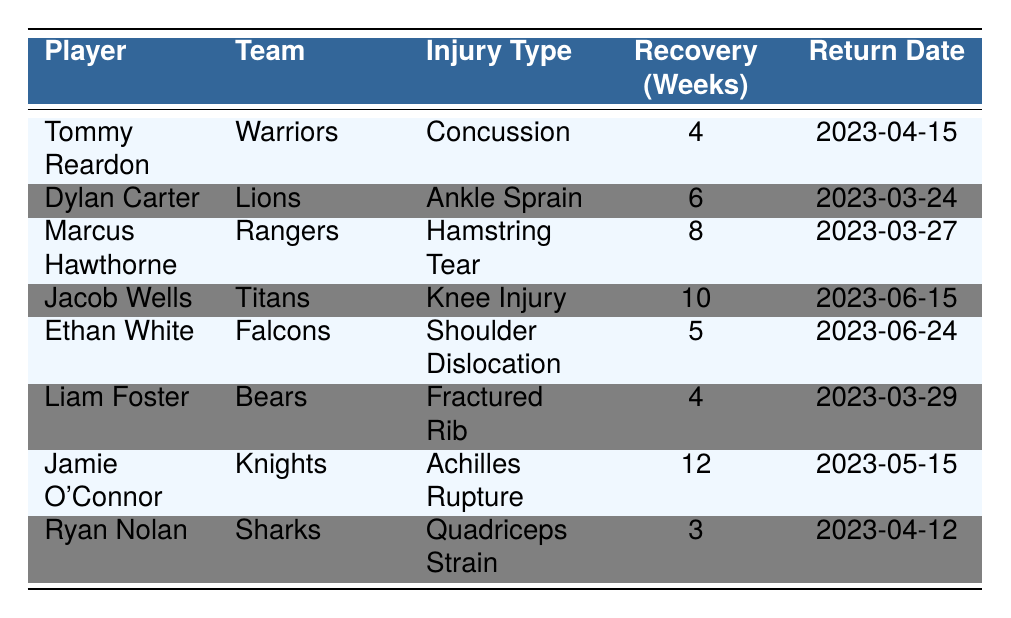What injury did Tommy Reardon have? Referring to the table, Tommy Reardon's injury type is listed as "Concussion."
Answer: Concussion Which player had the longest recovery time? By examining the recovery times in the table, Jamie O'Connor's recovery time is 12 weeks, which is the highest among all players.
Answer: Jamie O'Connor Did any players return to play before the 30th of April? Checking the return dates, both Tommy Reardon (April 15) and Liam Foster (March 29) returned before April 30.
Answer: Yes How many players sustained injuries that required more than 6 weeks of recovery? The table shows that Jamie O'Connor (12 weeks), Jacob Wells (10 weeks), and Marcus Hawthorne (8 weeks) had injuries requiring more than 6 weeks of recovery, totaling 3 players.
Answer: 3 players What is the average recovery time for the players listed? The recovery times are 4, 6, 8, 10, 5, 4, 12, and 3 weeks. Summing them yields 52 weeks for 8 players, so the average is 52/8 = 6.5 weeks.
Answer: 6.5 weeks Which team did Ryan Nolan play for, and what was his injury type? According to the table, Ryan Nolan played for the Sharks and sustained a Quadriceps Strain.
Answer: Sharks, Quadriceps Strain Is it true that all players returned to play within 12 weeks? Checking the return dates reveals that all listed players returned within their prescribed recovery times, and all times were less than or equal to 12 weeks.
Answer: Yes How many players had a return date after June 1? From the table, only Jacob Wells has a return date of June 15, which is after June 1, so there is 1 player.
Answer: 1 player What was the earliest injury date recorded in the table? Scanning the injury dates, Marcus Hawthorne's injury on January 30 is the earliest among the entries.
Answer: January 30 Who had a shoulder dislocation injury and when will they return? The table indicates that Ethan White had a Shoulder Dislocation injury and is expected to return on June 24.
Answer: Ethan White, June 24 